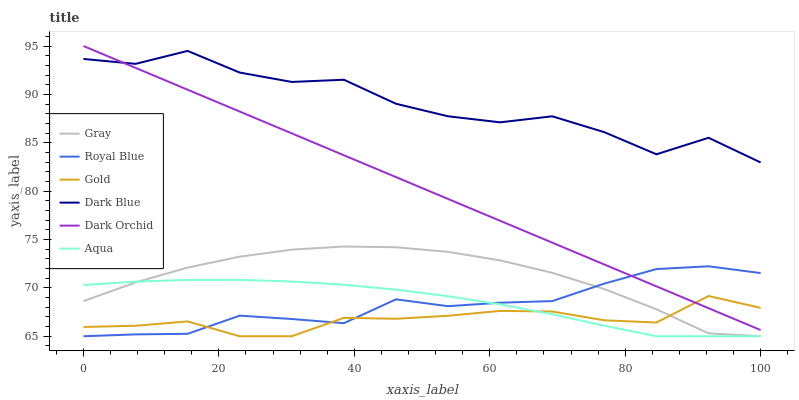Does Gold have the minimum area under the curve?
Answer yes or no. Yes. Does Dark Blue have the maximum area under the curve?
Answer yes or no. Yes. Does Royal Blue have the minimum area under the curve?
Answer yes or no. No. Does Royal Blue have the maximum area under the curve?
Answer yes or no. No. Is Dark Orchid the smoothest?
Answer yes or no. Yes. Is Dark Blue the roughest?
Answer yes or no. Yes. Is Gold the smoothest?
Answer yes or no. No. Is Gold the roughest?
Answer yes or no. No. Does Gray have the lowest value?
Answer yes or no. Yes. Does Dark Orchid have the lowest value?
Answer yes or no. No. Does Dark Orchid have the highest value?
Answer yes or no. Yes. Does Royal Blue have the highest value?
Answer yes or no. No. Is Gray less than Dark Blue?
Answer yes or no. Yes. Is Dark Blue greater than Aqua?
Answer yes or no. Yes. Does Dark Orchid intersect Dark Blue?
Answer yes or no. Yes. Is Dark Orchid less than Dark Blue?
Answer yes or no. No. Is Dark Orchid greater than Dark Blue?
Answer yes or no. No. Does Gray intersect Dark Blue?
Answer yes or no. No. 